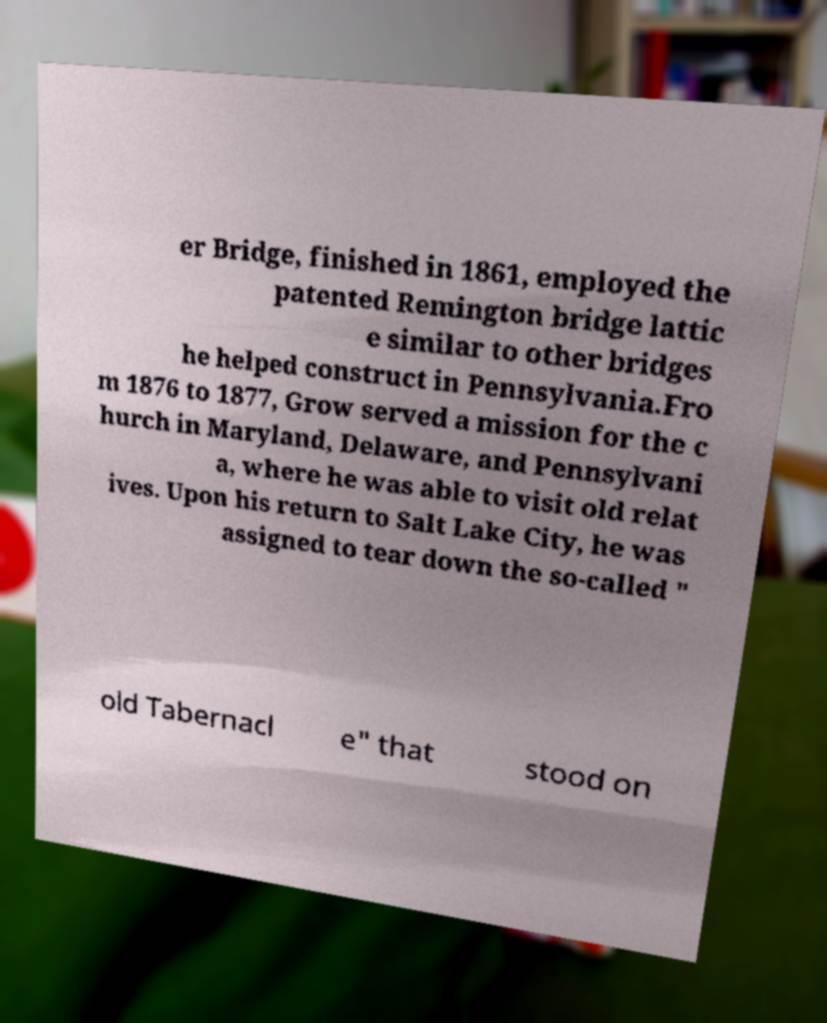I need the written content from this picture converted into text. Can you do that? er Bridge, finished in 1861, employed the patented Remington bridge lattic e similar to other bridges he helped construct in Pennsylvania.Fro m 1876 to 1877, Grow served a mission for the c hurch in Maryland, Delaware, and Pennsylvani a, where he was able to visit old relat ives. Upon his return to Salt Lake City, he was assigned to tear down the so-called " old Tabernacl e" that stood on 